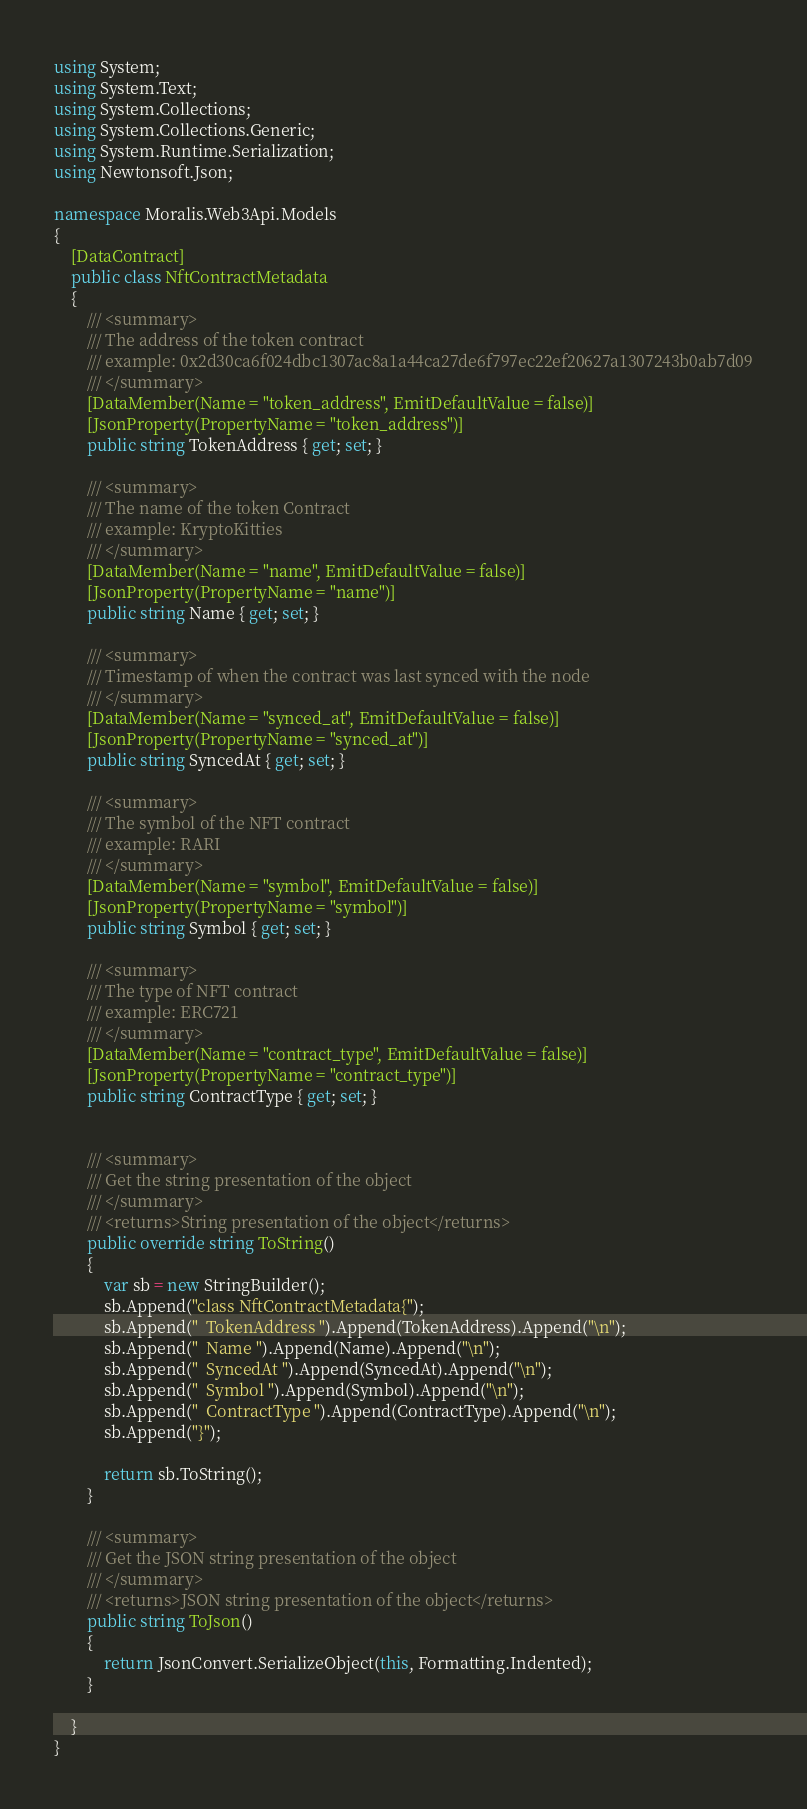<code> <loc_0><loc_0><loc_500><loc_500><_C#_>using System;
using System.Text;
using System.Collections;
using System.Collections.Generic;
using System.Runtime.Serialization;
using Newtonsoft.Json;

namespace Moralis.Web3Api.Models
{
	[DataContract]
	public class NftContractMetadata
	{
		/// <summary>
		/// The address of the token contract
		/// example: 0x2d30ca6f024dbc1307ac8a1a44ca27de6f797ec22ef20627a1307243b0ab7d09
		/// </summary>
		[DataMember(Name = "token_address", EmitDefaultValue = false)]
		[JsonProperty(PropertyName = "token_address")]
		public string TokenAddress { get; set; }

		/// <summary>
		/// The name of the token Contract
		/// example: KryptoKitties
		/// </summary>
		[DataMember(Name = "name", EmitDefaultValue = false)]
		[JsonProperty(PropertyName = "name")]
		public string Name { get; set; }

		/// <summary>
		/// Timestamp of when the contract was last synced with the node
		/// </summary>
		[DataMember(Name = "synced_at", EmitDefaultValue = false)]
		[JsonProperty(PropertyName = "synced_at")]
		public string SyncedAt { get; set; }

		/// <summary>
		/// The symbol of the NFT contract
		/// example: RARI
		/// </summary>
		[DataMember(Name = "symbol", EmitDefaultValue = false)]
		[JsonProperty(PropertyName = "symbol")]
		public string Symbol { get; set; }

		/// <summary>
		/// The type of NFT contract
		/// example: ERC721
		/// </summary>
		[DataMember(Name = "contract_type", EmitDefaultValue = false)]
		[JsonProperty(PropertyName = "contract_type")]
		public string ContractType { get; set; }


		/// <summary>
		/// Get the string presentation of the object
		/// </summary>
		/// <returns>String presentation of the object</returns>
		public override string ToString()
		{
			var sb = new StringBuilder();
			sb.Append("class NftContractMetadata{");
			sb.Append("  TokenAddress ").Append(TokenAddress).Append("\n");
			sb.Append("  Name ").Append(Name).Append("\n");
			sb.Append("  SyncedAt ").Append(SyncedAt).Append("\n");
			sb.Append("  Symbol ").Append(Symbol).Append("\n");
			sb.Append("  ContractType ").Append(ContractType).Append("\n");
			sb.Append("}");

			return sb.ToString();
		}

		/// <summary>
		/// Get the JSON string presentation of the object
		/// </summary>
		/// <returns>JSON string presentation of the object</returns>
		public string ToJson()
		{
			return JsonConvert.SerializeObject(this, Formatting.Indented);
		}

	}
}</code> 